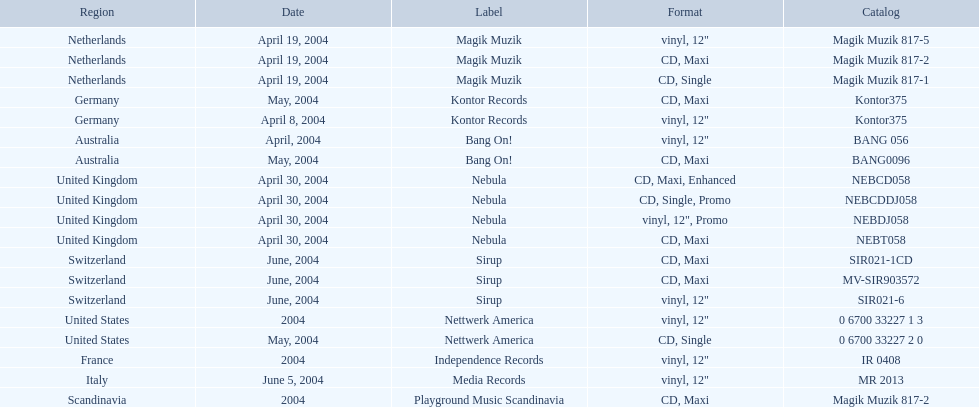What branding was adopted by the netherlands in love comes again? Magik Muzik. What branding was adopted in germany? Kontor Records. What branding was adopted in france? Independence Records. 